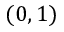<formula> <loc_0><loc_0><loc_500><loc_500>( 0 , 1 )</formula> 